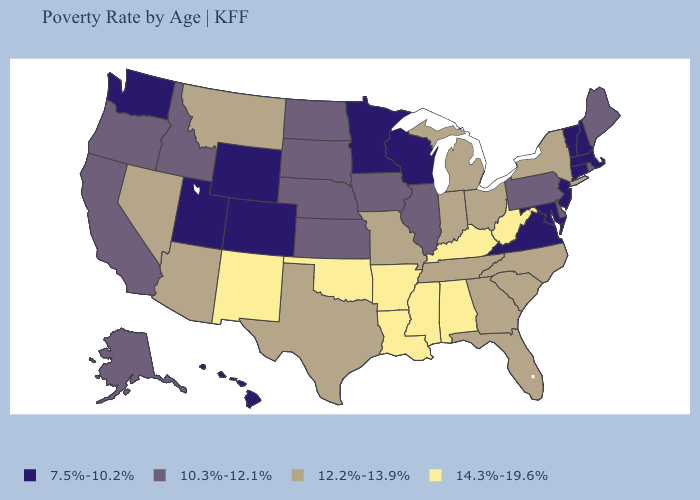What is the value of Utah?
Write a very short answer. 7.5%-10.2%. Does Iowa have a higher value than New Jersey?
Concise answer only. Yes. What is the value of Massachusetts?
Answer briefly. 7.5%-10.2%. Among the states that border Rhode Island , which have the lowest value?
Short answer required. Connecticut, Massachusetts. What is the value of Montana?
Answer briefly. 12.2%-13.9%. What is the value of Connecticut?
Quick response, please. 7.5%-10.2%. What is the value of Arkansas?
Give a very brief answer. 14.3%-19.6%. Does Texas have the lowest value in the USA?
Answer briefly. No. Name the states that have a value in the range 10.3%-12.1%?
Be succinct. Alaska, California, Delaware, Idaho, Illinois, Iowa, Kansas, Maine, Nebraska, North Dakota, Oregon, Pennsylvania, Rhode Island, South Dakota. How many symbols are there in the legend?
Short answer required. 4. Name the states that have a value in the range 10.3%-12.1%?
Be succinct. Alaska, California, Delaware, Idaho, Illinois, Iowa, Kansas, Maine, Nebraska, North Dakota, Oregon, Pennsylvania, Rhode Island, South Dakota. What is the value of New Jersey?
Write a very short answer. 7.5%-10.2%. What is the highest value in the MidWest ?
Concise answer only. 12.2%-13.9%. Does Arkansas have the highest value in the USA?
Answer briefly. Yes. Among the states that border Minnesota , does South Dakota have the highest value?
Be succinct. Yes. 